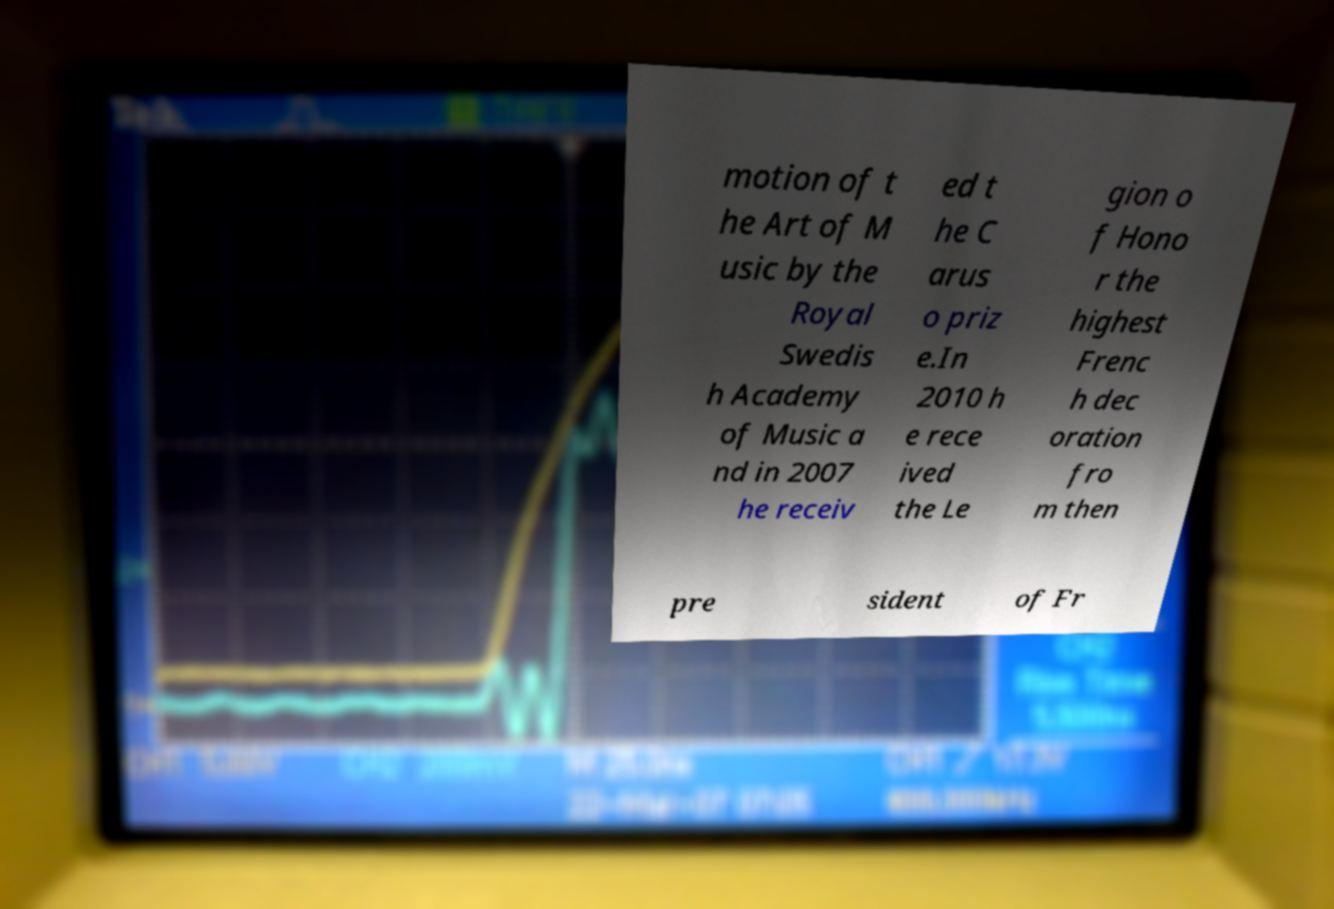Could you extract and type out the text from this image? motion of t he Art of M usic by the Royal Swedis h Academy of Music a nd in 2007 he receiv ed t he C arus o priz e.In 2010 h e rece ived the Le gion o f Hono r the highest Frenc h dec oration fro m then pre sident of Fr 